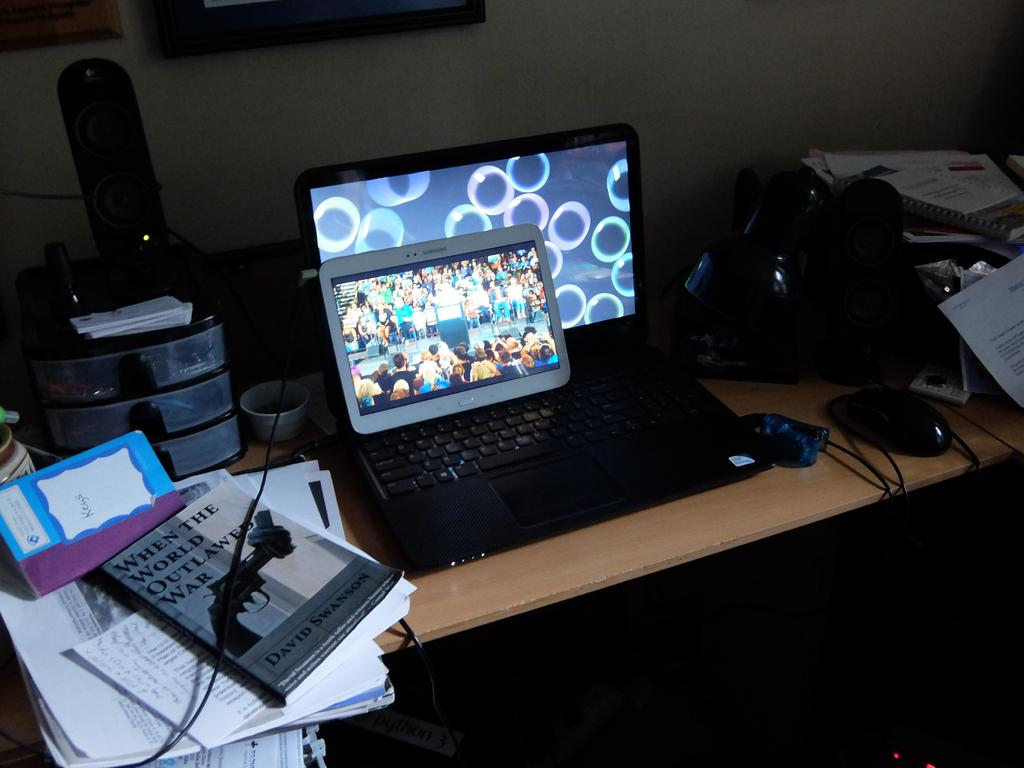<image>
Give a short and clear explanation of the subsequent image. David Swanson wrote a book titled "When The World Outlawed War". 